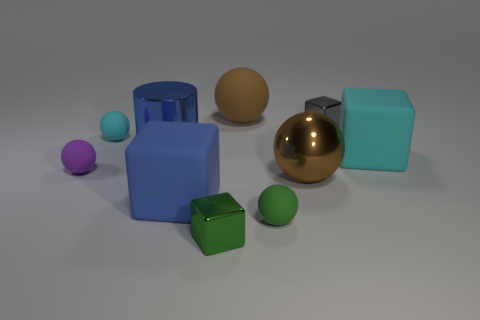Is the metal sphere the same color as the large rubber ball?
Make the answer very short. Yes. What is the color of the big block left of the small gray cube that is to the right of the tiny cyan object?
Your answer should be very brief. Blue. How many tiny objects are cubes or cyan matte cylinders?
Make the answer very short. 2. The shiny object that is both left of the big shiny sphere and on the right side of the big blue metal object is what color?
Provide a short and direct response. Green. Are the large blue cylinder and the small purple sphere made of the same material?
Give a very brief answer. No. The purple matte object has what shape?
Ensure brevity in your answer.  Sphere. How many spheres are behind the brown thing that is behind the big brown sphere that is in front of the blue cylinder?
Offer a terse response. 0. The other big matte object that is the same shape as the big cyan rubber object is what color?
Your response must be concise. Blue. There is a large brown thing in front of the blue thing that is behind the large block behind the large metal sphere; what shape is it?
Offer a very short reply. Sphere. There is a matte thing that is on the right side of the big blue metal cylinder and behind the large cyan matte cube; what size is it?
Keep it short and to the point. Large. 